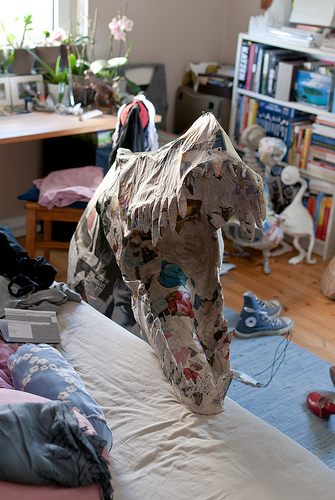<image>
Is there a plant behind the window? No. The plant is not behind the window. From this viewpoint, the plant appears to be positioned elsewhere in the scene. 